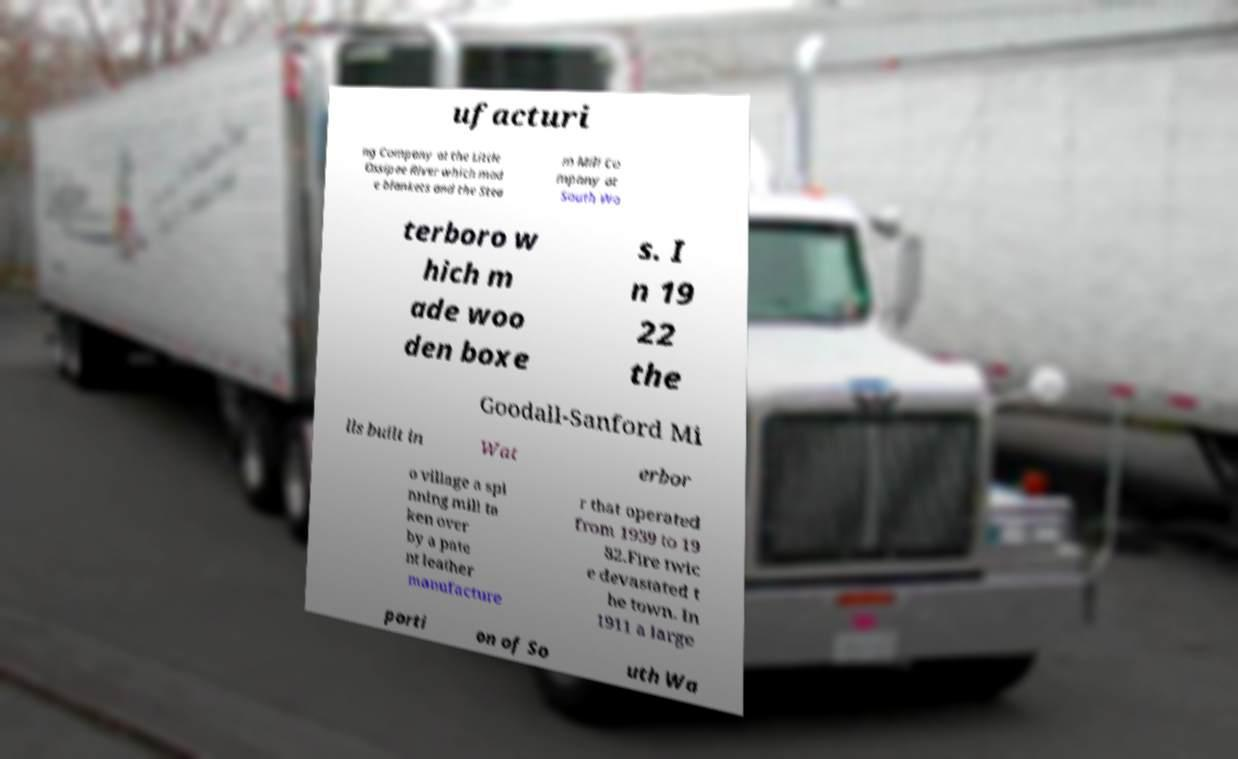What messages or text are displayed in this image? I need them in a readable, typed format. ufacturi ng Company at the Little Ossipee River which mad e blankets and the Stea m Mill Co mpany at South Wa terboro w hich m ade woo den boxe s. I n 19 22 the Goodall-Sanford Mi lls built in Wat erbor o village a spi nning mill ta ken over by a pate nt leather manufacture r that operated from 1939 to 19 82.Fire twic e devastated t he town. In 1911 a large porti on of So uth Wa 